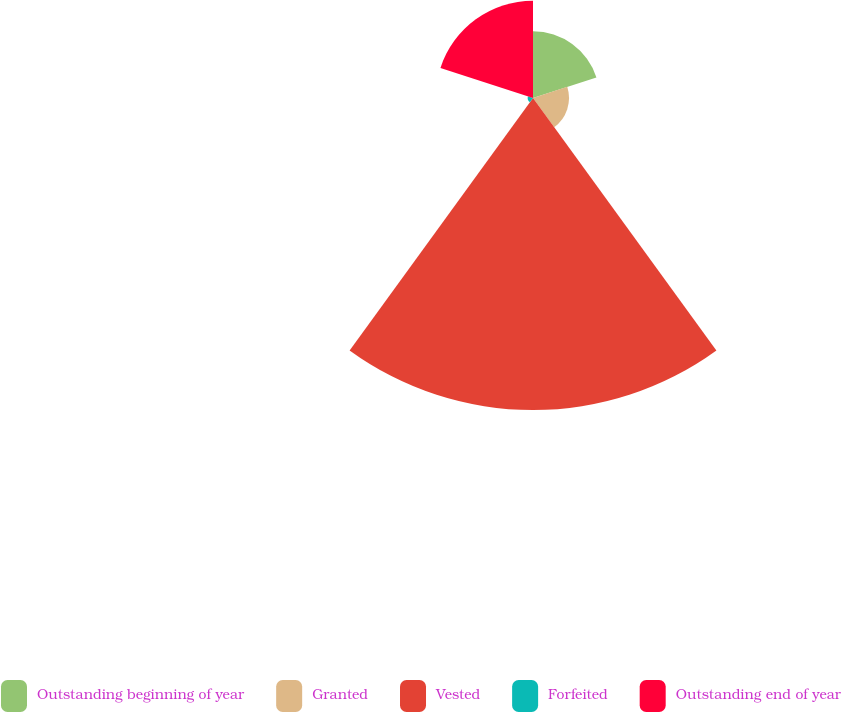Convert chart. <chart><loc_0><loc_0><loc_500><loc_500><pie_chart><fcel>Outstanding beginning of year<fcel>Granted<fcel>Vested<fcel>Forfeited<fcel>Outstanding end of year<nl><fcel>12.89%<fcel>6.96%<fcel>60.31%<fcel>1.03%<fcel>18.81%<nl></chart> 